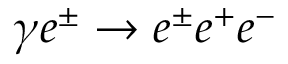<formula> <loc_0><loc_0><loc_500><loc_500>\gamma e ^ { \pm } \rightarrow e ^ { \pm } e ^ { + } e ^ { - }</formula> 